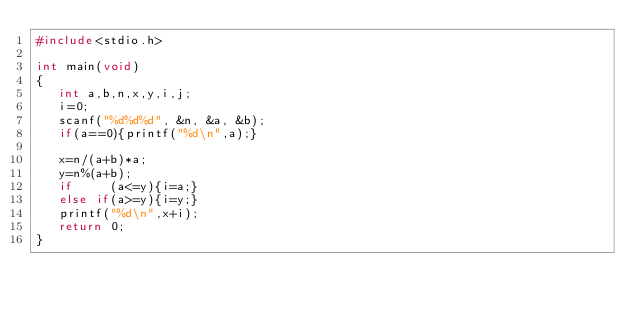Convert code to text. <code><loc_0><loc_0><loc_500><loc_500><_C_>#include<stdio.h>

int main(void)
{
   int a,b,n,x,y,i,j;
   i=0;
   scanf("%d%d%d", &n, &a, &b);
   if(a==0){printf("%d\n",a);}

   x=n/(a+b)*a;
   y=n%(a+b);
   if     (a<=y){i=a;}
   else if(a>=y){i=y;}
   printf("%d\n",x+i);
   return 0;
}
</code> 